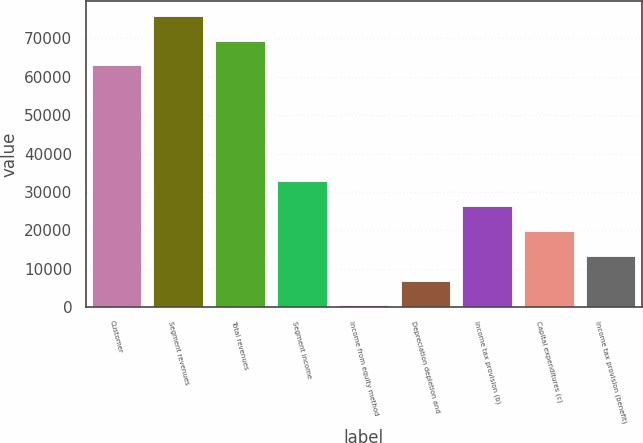<chart> <loc_0><loc_0><loc_500><loc_500><bar_chart><fcel>Customer<fcel>Segment revenues<fcel>Total revenues<fcel>Segment income<fcel>Income from equity method<fcel>Depreciation depletion and<fcel>Income tax provision (b)<fcel>Capital expenditures (c)<fcel>Income tax provision (benefit)<nl><fcel>62976<fcel>75923.8<fcel>69449.9<fcel>32760.5<fcel>391<fcel>6864.9<fcel>26286.6<fcel>19812.7<fcel>13338.8<nl></chart> 